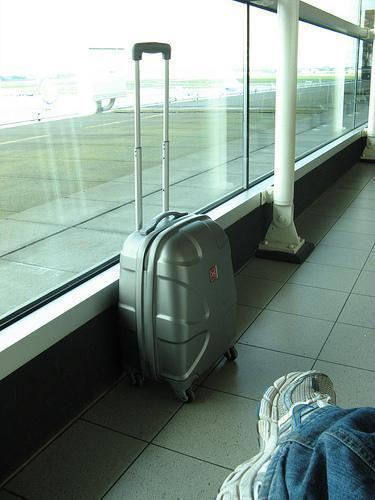How many shoes?
Give a very brief answer. 1. How many suitcases?
Give a very brief answer. 1. How many red clothing articles are visible in the picture?
Give a very brief answer. 0. 